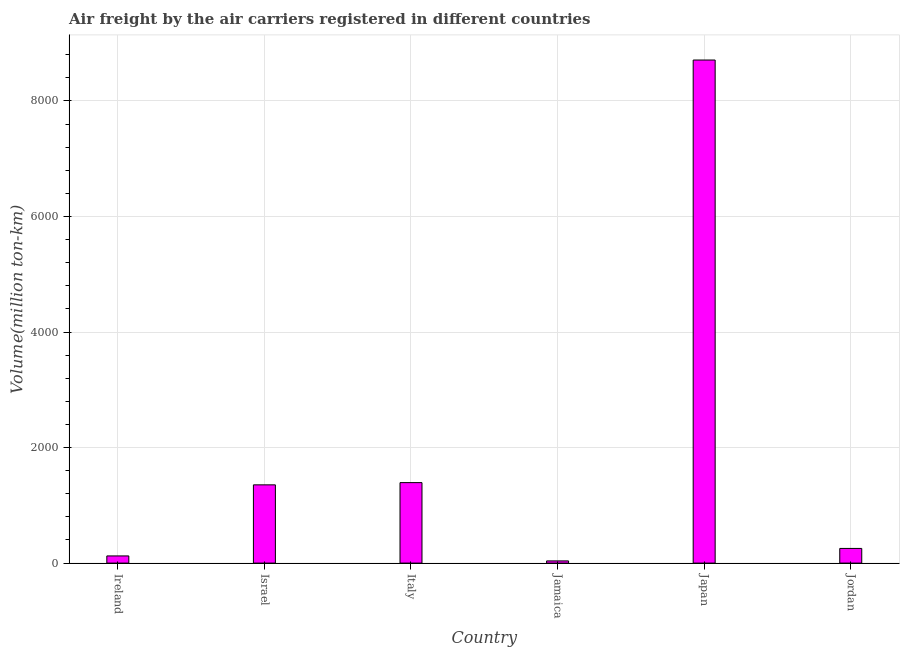What is the title of the graph?
Your answer should be compact. Air freight by the air carriers registered in different countries. What is the label or title of the Y-axis?
Ensure brevity in your answer.  Volume(million ton-km). What is the air freight in Japan?
Provide a short and direct response. 8708.24. Across all countries, what is the maximum air freight?
Give a very brief answer. 8708.24. Across all countries, what is the minimum air freight?
Offer a very short reply. 37.7. In which country was the air freight maximum?
Give a very brief answer. Japan. In which country was the air freight minimum?
Provide a short and direct response. Jamaica. What is the sum of the air freight?
Offer a very short reply. 1.19e+04. What is the difference between the air freight in Japan and Jordan?
Offer a terse response. 8454.4. What is the average air freight per country?
Give a very brief answer. 1978.58. What is the median air freight?
Your response must be concise. 804.19. What is the ratio of the air freight in Italy to that in Jamaica?
Your answer should be compact. 36.95. What is the difference between the highest and the second highest air freight?
Make the answer very short. 7315.21. Is the sum of the air freight in Ireland and Japan greater than the maximum air freight across all countries?
Provide a succinct answer. Yes. What is the difference between the highest and the lowest air freight?
Keep it short and to the point. 8670.55. In how many countries, is the air freight greater than the average air freight taken over all countries?
Give a very brief answer. 1. How many bars are there?
Your answer should be very brief. 6. What is the difference between two consecutive major ticks on the Y-axis?
Give a very brief answer. 2000. What is the Volume(million ton-km) in Ireland?
Provide a short and direct response. 124.11. What is the Volume(million ton-km) of Israel?
Provide a succinct answer. 1354.54. What is the Volume(million ton-km) in Italy?
Provide a short and direct response. 1393.04. What is the Volume(million ton-km) of Jamaica?
Keep it short and to the point. 37.7. What is the Volume(million ton-km) of Japan?
Make the answer very short. 8708.24. What is the Volume(million ton-km) in Jordan?
Provide a succinct answer. 253.84. What is the difference between the Volume(million ton-km) in Ireland and Israel?
Give a very brief answer. -1230.43. What is the difference between the Volume(million ton-km) in Ireland and Italy?
Give a very brief answer. -1268.93. What is the difference between the Volume(million ton-km) in Ireland and Jamaica?
Your response must be concise. 86.41. What is the difference between the Volume(million ton-km) in Ireland and Japan?
Your answer should be compact. -8584.13. What is the difference between the Volume(million ton-km) in Ireland and Jordan?
Make the answer very short. -129.74. What is the difference between the Volume(million ton-km) in Israel and Italy?
Provide a succinct answer. -38.5. What is the difference between the Volume(million ton-km) in Israel and Jamaica?
Ensure brevity in your answer.  1316.84. What is the difference between the Volume(million ton-km) in Israel and Japan?
Provide a succinct answer. -7353.71. What is the difference between the Volume(million ton-km) in Israel and Jordan?
Offer a very short reply. 1100.69. What is the difference between the Volume(million ton-km) in Italy and Jamaica?
Your response must be concise. 1355.34. What is the difference between the Volume(million ton-km) in Italy and Japan?
Ensure brevity in your answer.  -7315.21. What is the difference between the Volume(million ton-km) in Italy and Jordan?
Your answer should be very brief. 1139.19. What is the difference between the Volume(million ton-km) in Jamaica and Japan?
Offer a very short reply. -8670.55. What is the difference between the Volume(million ton-km) in Jamaica and Jordan?
Make the answer very short. -216.15. What is the difference between the Volume(million ton-km) in Japan and Jordan?
Keep it short and to the point. 8454.4. What is the ratio of the Volume(million ton-km) in Ireland to that in Israel?
Give a very brief answer. 0.09. What is the ratio of the Volume(million ton-km) in Ireland to that in Italy?
Provide a succinct answer. 0.09. What is the ratio of the Volume(million ton-km) in Ireland to that in Jamaica?
Your answer should be very brief. 3.29. What is the ratio of the Volume(million ton-km) in Ireland to that in Japan?
Provide a short and direct response. 0.01. What is the ratio of the Volume(million ton-km) in Ireland to that in Jordan?
Provide a short and direct response. 0.49. What is the ratio of the Volume(million ton-km) in Israel to that in Italy?
Your answer should be compact. 0.97. What is the ratio of the Volume(million ton-km) in Israel to that in Jamaica?
Offer a terse response. 35.93. What is the ratio of the Volume(million ton-km) in Israel to that in Japan?
Your response must be concise. 0.16. What is the ratio of the Volume(million ton-km) in Israel to that in Jordan?
Keep it short and to the point. 5.34. What is the ratio of the Volume(million ton-km) in Italy to that in Jamaica?
Provide a succinct answer. 36.95. What is the ratio of the Volume(million ton-km) in Italy to that in Japan?
Provide a short and direct response. 0.16. What is the ratio of the Volume(million ton-km) in Italy to that in Jordan?
Offer a very short reply. 5.49. What is the ratio of the Volume(million ton-km) in Jamaica to that in Japan?
Offer a very short reply. 0. What is the ratio of the Volume(million ton-km) in Jamaica to that in Jordan?
Provide a short and direct response. 0.15. What is the ratio of the Volume(million ton-km) in Japan to that in Jordan?
Provide a short and direct response. 34.3. 